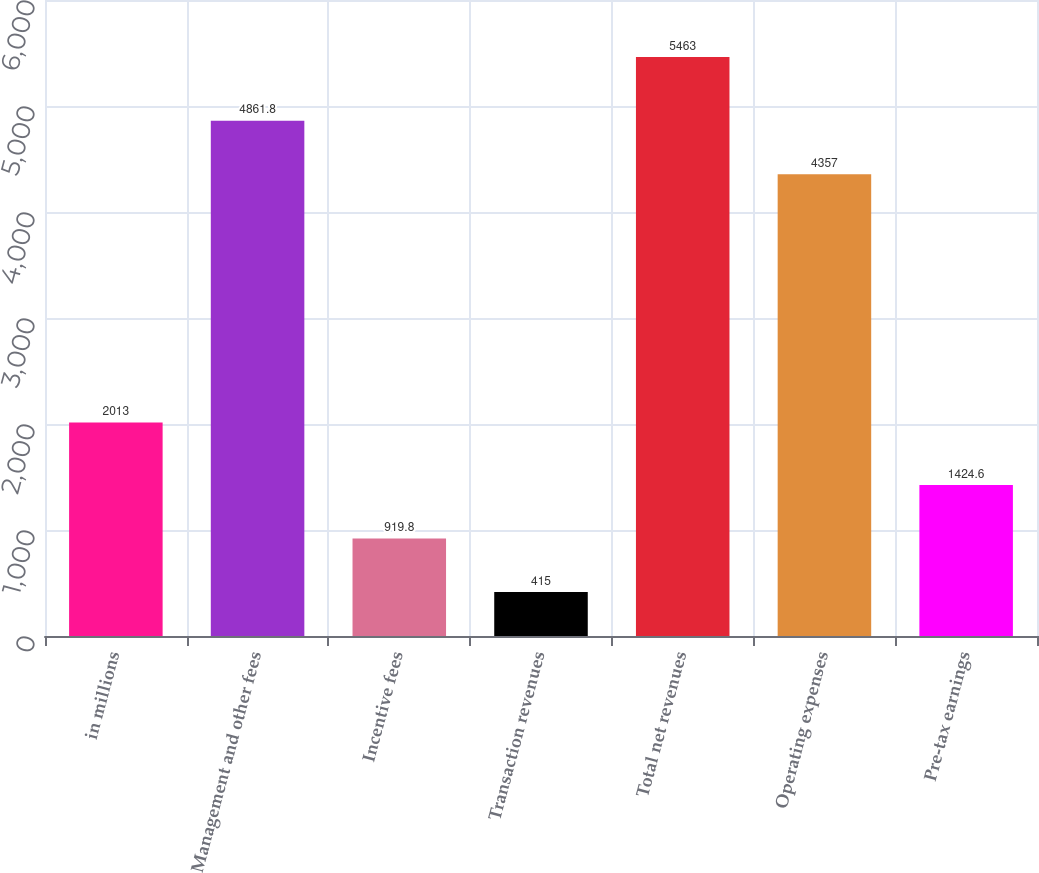Convert chart to OTSL. <chart><loc_0><loc_0><loc_500><loc_500><bar_chart><fcel>in millions<fcel>Management and other fees<fcel>Incentive fees<fcel>Transaction revenues<fcel>Total net revenues<fcel>Operating expenses<fcel>Pre-tax earnings<nl><fcel>2013<fcel>4861.8<fcel>919.8<fcel>415<fcel>5463<fcel>4357<fcel>1424.6<nl></chart> 